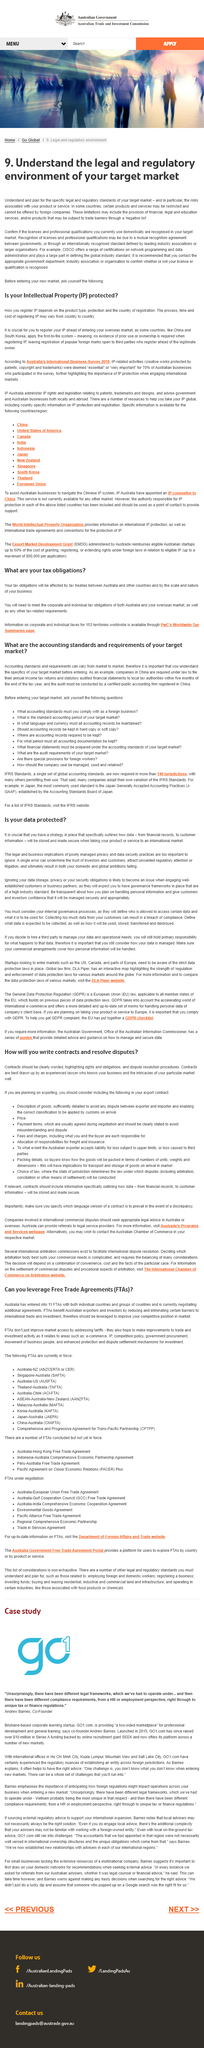Draw attention to some important aspects in this diagram. We understand the importance of comprehending the legal and regulatory environment of our target market, and prioritize the evaluation and analysis of the specific legal and regulatory standards that apply to our products or services and the associated risks. We verify if our current licenses and professional qualifications are recognized in our target market. It is recommended that you contact the appropriate government department, industry association or organization to confirm whether your license is required or recognized in your target market. A negative list is a list of financial, legal, educational services and/or products that may be subject to trade barriers and restrictions. This list specifically identifies the provisions that are allowed and not subject to trade limitations. 